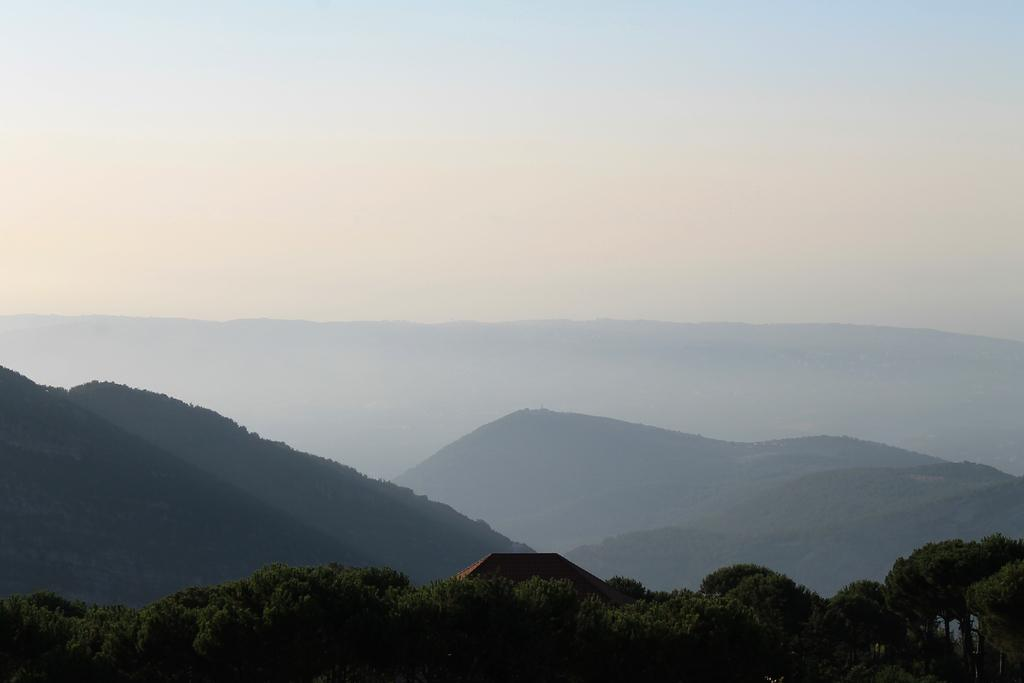What type of vegetation can be seen in the image? There are trees in the image. What is the color of the trees? The trees are green in color. What other structures are present in the image? There are buildings in the image. What can be seen in the distance in the image? There are mountains visible in the background of the image. What is visible above the trees and buildings in the image? The sky is visible in the background of the image. What type of silk fabric is draped over the mountains in the image? There is no silk fabric present in the image; the mountains are visible in the background without any fabric draped over them. 